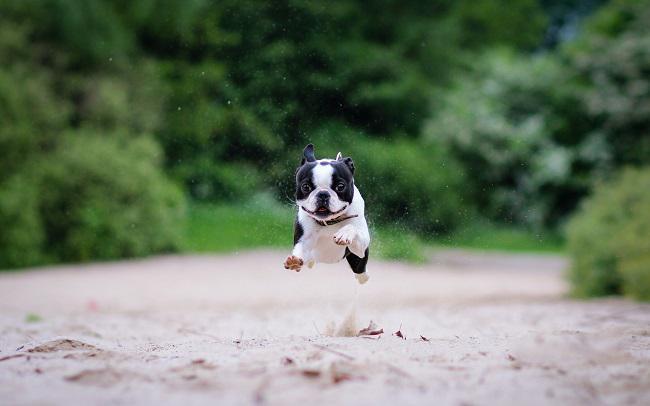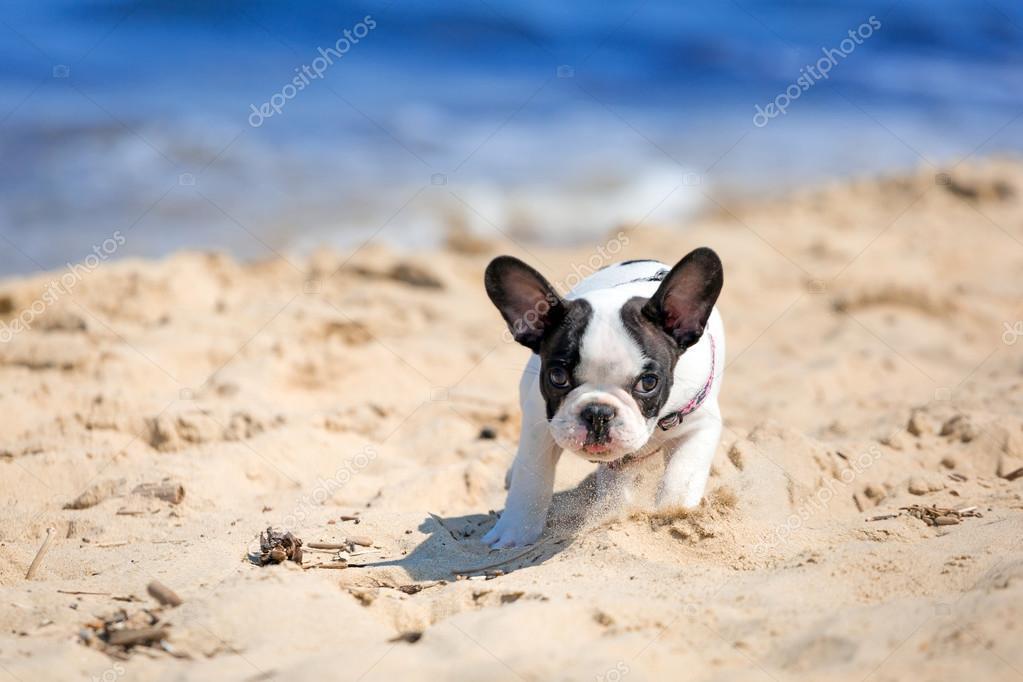The first image is the image on the left, the second image is the image on the right. Considering the images on both sides, is "The right image shows a black and white french bulldog puppy running on sand" valid? Answer yes or no. Yes. 